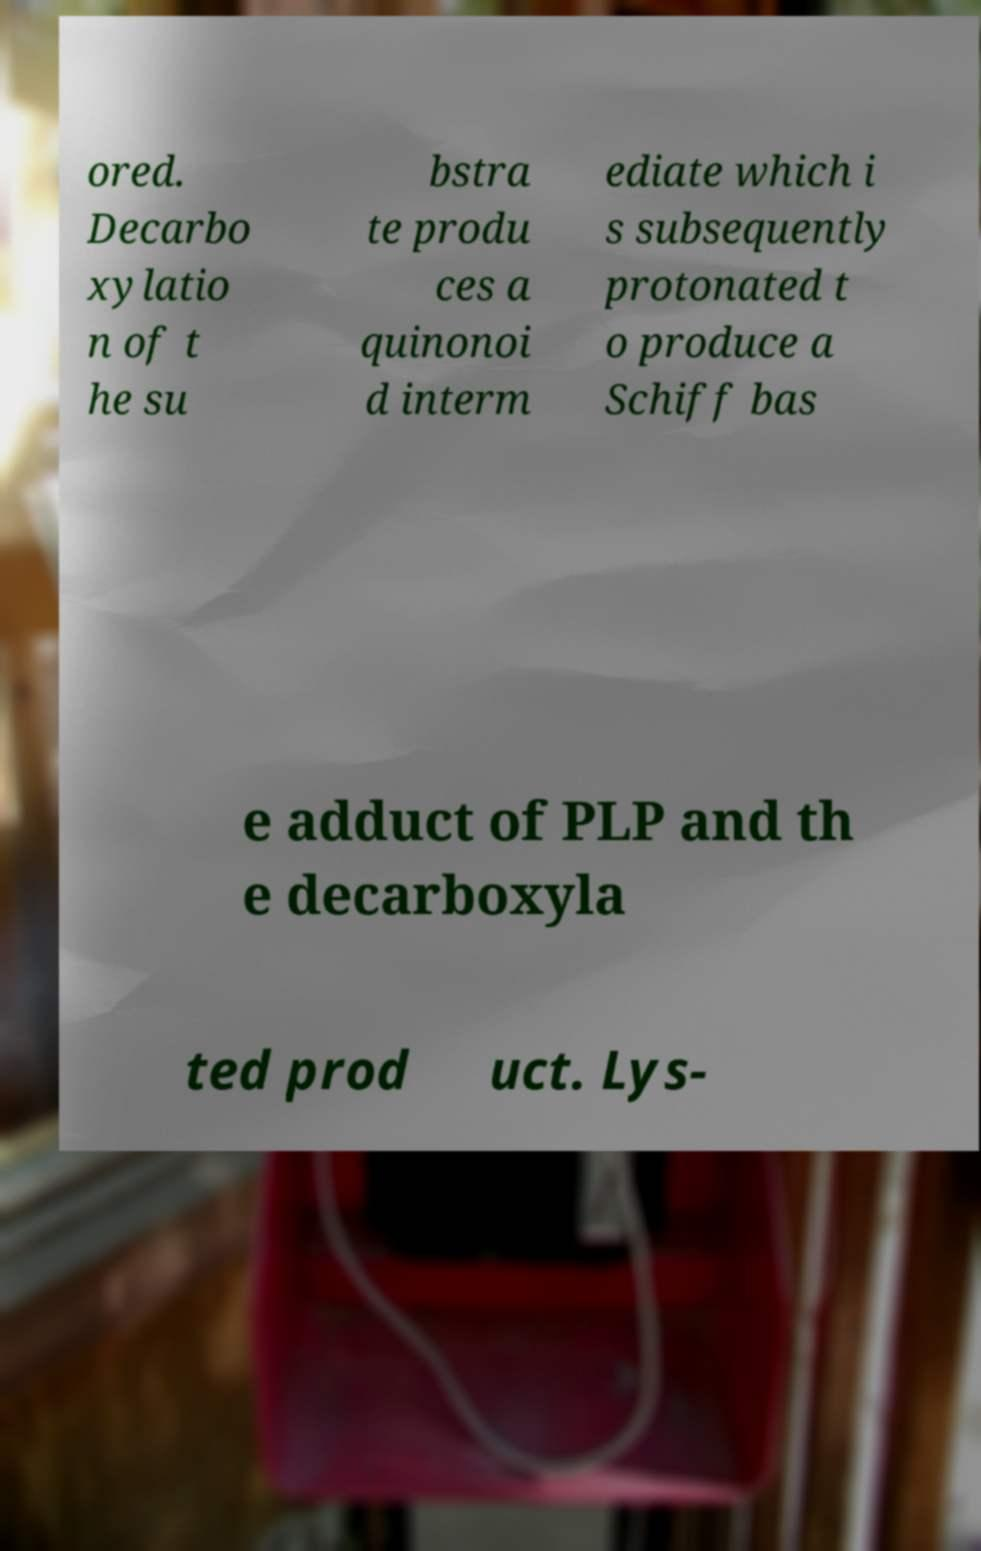Could you extract and type out the text from this image? ored. Decarbo xylatio n of t he su bstra te produ ces a quinonoi d interm ediate which i s subsequently protonated t o produce a Schiff bas e adduct of PLP and th e decarboxyla ted prod uct. Lys- 